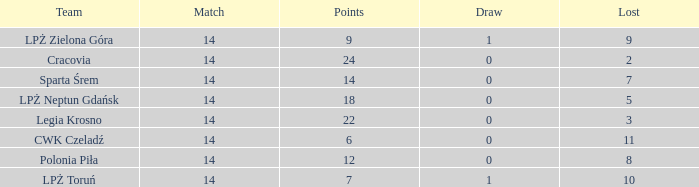What is the lowest points for a match before 14? None. 